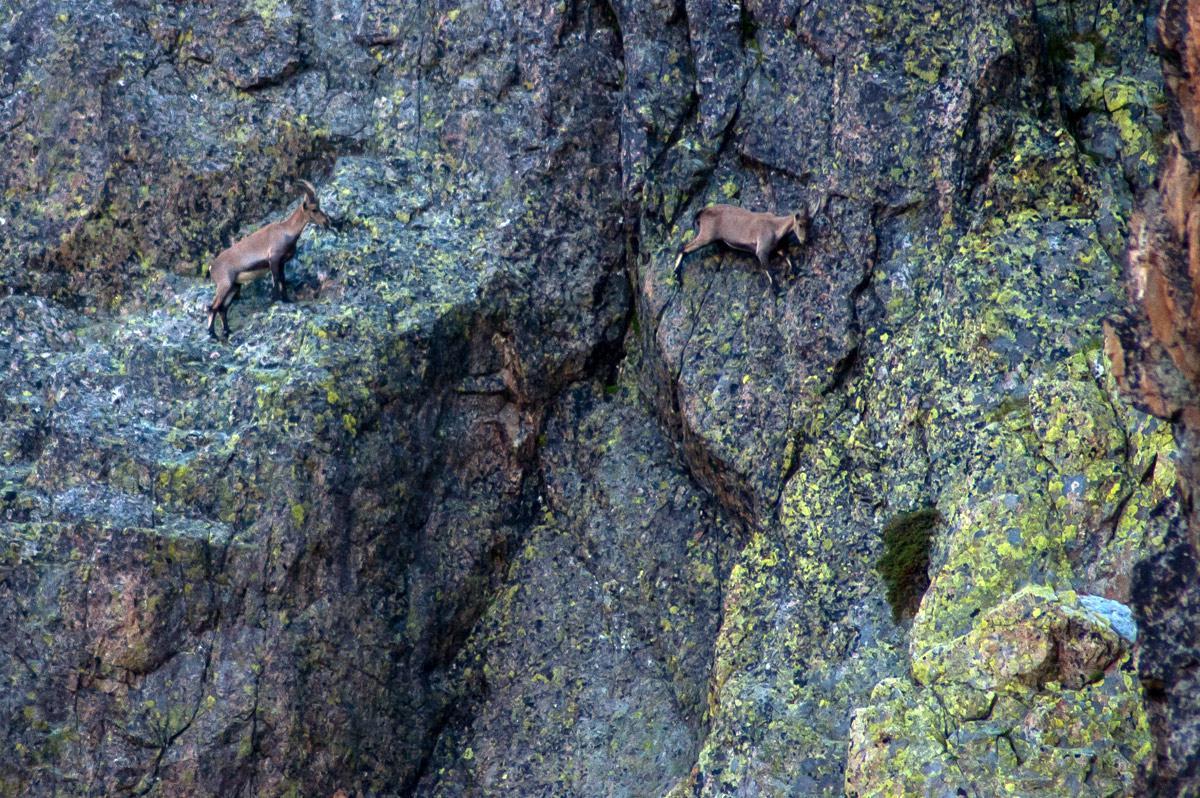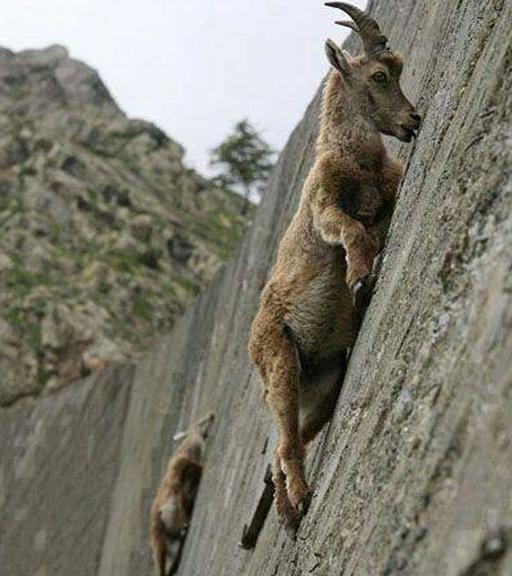The first image is the image on the left, the second image is the image on the right. Analyze the images presented: Is the assertion "Some of the animals are on a steep rock face." valid? Answer yes or no. Yes. The first image is the image on the left, the second image is the image on the right. Examine the images to the left and right. Is the description "The right photo contains three or more animals." accurate? Answer yes or no. No. 